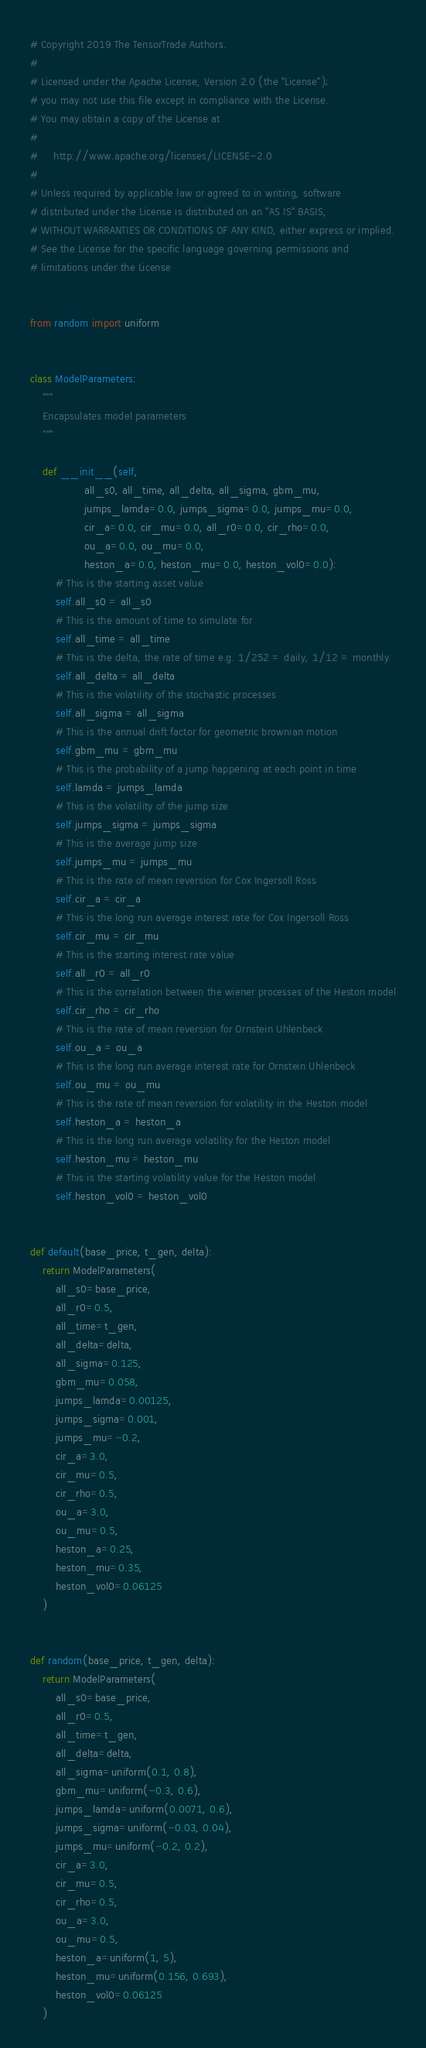Convert code to text. <code><loc_0><loc_0><loc_500><loc_500><_Python_># Copyright 2019 The TensorTrade Authors.
#
# Licensed under the Apache License, Version 2.0 (the "License");
# you may not use this file except in compliance with the License.
# You may obtain a copy of the License at
#
#     http://www.apache.org/licenses/LICENSE-2.0
#
# Unless required by applicable law or agreed to in writing, software
# distributed under the License is distributed on an "AS IS" BASIS,
# WITHOUT WARRANTIES OR CONDITIONS OF ANY KIND, either express or implied.
# See the License for the specific language governing permissions and
# limitations under the License


from random import uniform


class ModelParameters:
    """
    Encapsulates model parameters
    """

    def __init__(self,
                 all_s0, all_time, all_delta, all_sigma, gbm_mu,
                 jumps_lamda=0.0, jumps_sigma=0.0, jumps_mu=0.0,
                 cir_a=0.0, cir_mu=0.0, all_r0=0.0, cir_rho=0.0,
                 ou_a=0.0, ou_mu=0.0,
                 heston_a=0.0, heston_mu=0.0, heston_vol0=0.0):
        # This is the starting asset value
        self.all_s0 = all_s0
        # This is the amount of time to simulate for
        self.all_time = all_time
        # This is the delta, the rate of time e.g. 1/252 = daily, 1/12 = monthly
        self.all_delta = all_delta
        # This is the volatility of the stochastic processes
        self.all_sigma = all_sigma
        # This is the annual drift factor for geometric brownian motion
        self.gbm_mu = gbm_mu
        # This is the probability of a jump happening at each point in time
        self.lamda = jumps_lamda
        # This is the volatility of the jump size
        self.jumps_sigma = jumps_sigma
        # This is the average jump size
        self.jumps_mu = jumps_mu
        # This is the rate of mean reversion for Cox Ingersoll Ross
        self.cir_a = cir_a
        # This is the long run average interest rate for Cox Ingersoll Ross
        self.cir_mu = cir_mu
        # This is the starting interest rate value
        self.all_r0 = all_r0
        # This is the correlation between the wiener processes of the Heston model
        self.cir_rho = cir_rho
        # This is the rate of mean reversion for Ornstein Uhlenbeck
        self.ou_a = ou_a
        # This is the long run average interest rate for Ornstein Uhlenbeck
        self.ou_mu = ou_mu
        # This is the rate of mean reversion for volatility in the Heston model
        self.heston_a = heston_a
        # This is the long run average volatility for the Heston model
        self.heston_mu = heston_mu
        # This is the starting volatility value for the Heston model
        self.heston_vol0 = heston_vol0


def default(base_price, t_gen, delta):
    return ModelParameters(
        all_s0=base_price,
        all_r0=0.5,
        all_time=t_gen,
        all_delta=delta,
        all_sigma=0.125,
        gbm_mu=0.058,
        jumps_lamda=0.00125,
        jumps_sigma=0.001,
        jumps_mu=-0.2,
        cir_a=3.0,
        cir_mu=0.5,
        cir_rho=0.5,
        ou_a=3.0,
        ou_mu=0.5,
        heston_a=0.25,
        heston_mu=0.35,
        heston_vol0=0.06125
    )


def random(base_price, t_gen, delta):
    return ModelParameters(
        all_s0=base_price,
        all_r0=0.5,
        all_time=t_gen,
        all_delta=delta,
        all_sigma=uniform(0.1, 0.8),
        gbm_mu=uniform(-0.3, 0.6),
        jumps_lamda=uniform(0.0071, 0.6),
        jumps_sigma=uniform(-0.03, 0.04),
        jumps_mu=uniform(-0.2, 0.2),
        cir_a=3.0,
        cir_mu=0.5,
        cir_rho=0.5,
        ou_a=3.0,
        ou_mu=0.5,
        heston_a=uniform(1, 5),
        heston_mu=uniform(0.156, 0.693),
        heston_vol0=0.06125
    )
</code> 